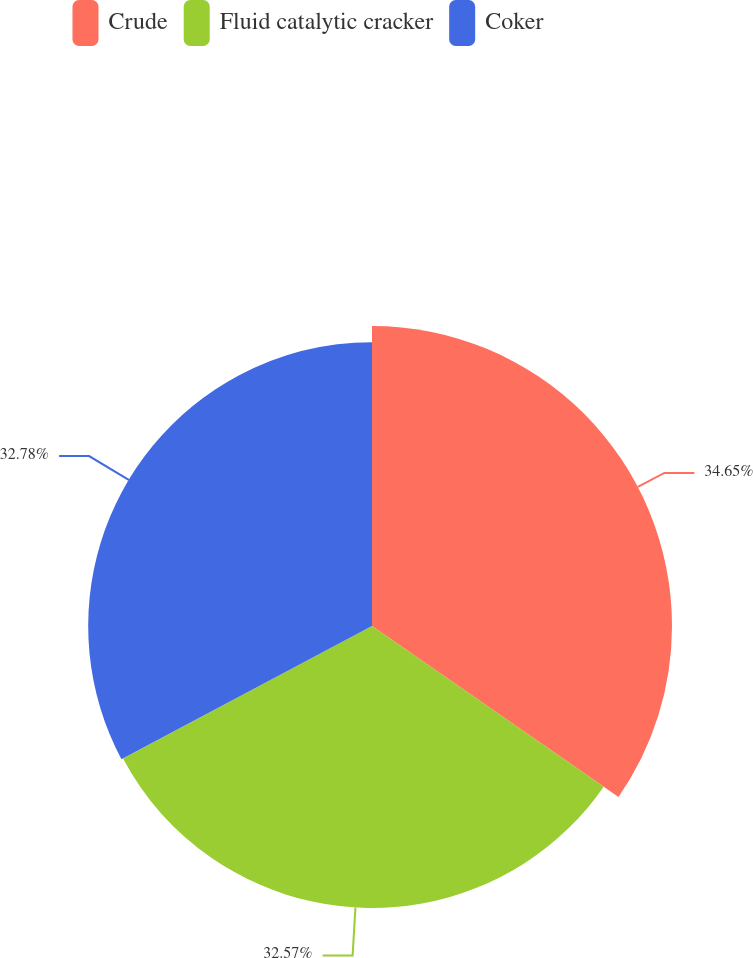Convert chart. <chart><loc_0><loc_0><loc_500><loc_500><pie_chart><fcel>Crude<fcel>Fluid catalytic cracker<fcel>Coker<nl><fcel>34.65%<fcel>32.57%<fcel>32.78%<nl></chart> 